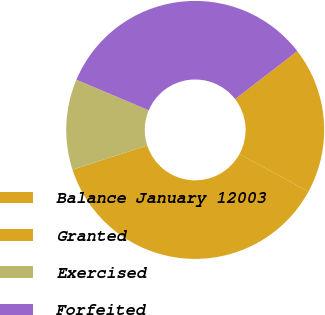Convert chart to OTSL. <chart><loc_0><loc_0><loc_500><loc_500><pie_chart><fcel>Balance January 12003<fcel>Granted<fcel>Exercised<fcel>Forfeited<nl><fcel>18.39%<fcel>37.08%<fcel>11.36%<fcel>33.18%<nl></chart> 